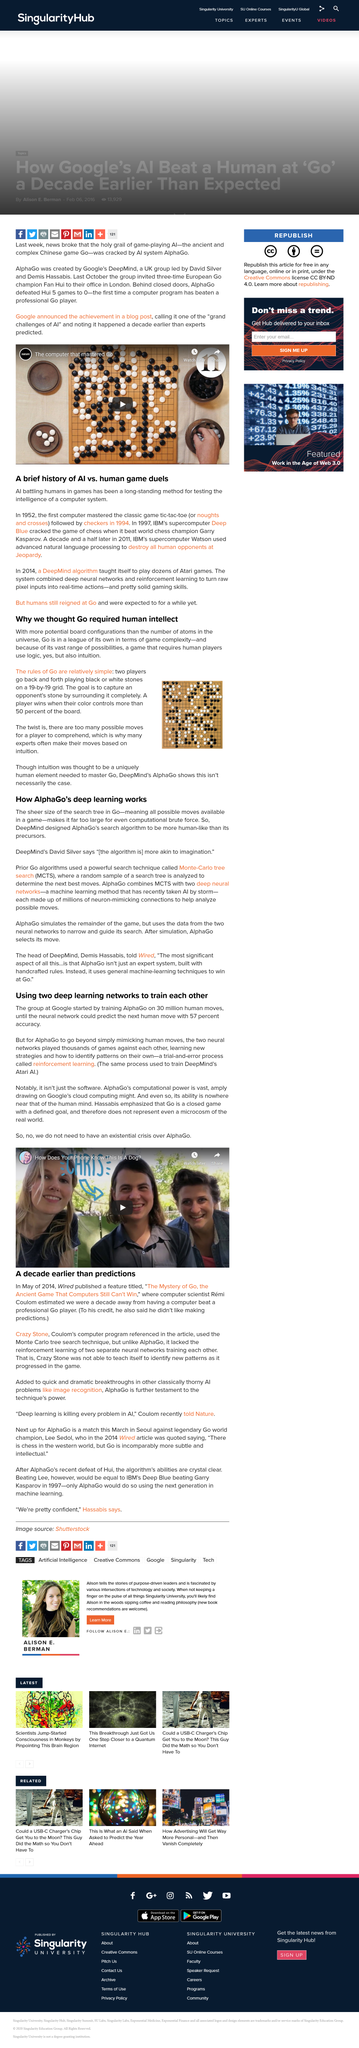Point out several critical features in this image. DeepMind, led by David Silver and Demis Hassabis, is a company that specializes in artificial intelligence research and development. Yes, DeepMind designed AlphaGo to be more human-like than its precursors. Monte-Carlo tree search is a method of determining the best move in a game or decision-making problem by simulating many possible variations of the game and selecting the one that results in the most favorable outcome. MCTS stands for Monte-Carlo tree search, which is a type of algorithm that uses random sampling to explore the possible outcomes of a given situation. In its progress through the game, Crazy Stone was unable to teach itself to identify new patterns, despite its advanced abilities. After simulating all possible moves and their outcomes, AlphaGo selects the best move to make based on its evaluation of the board position and the strength of its opponent's potential responses. 